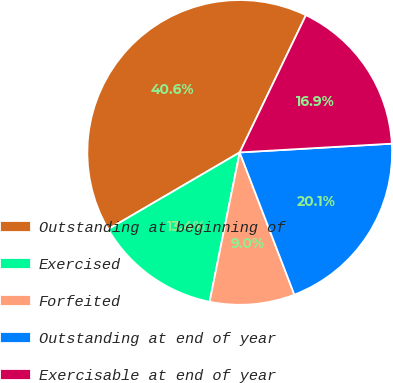<chart> <loc_0><loc_0><loc_500><loc_500><pie_chart><fcel>Outstanding at beginning of<fcel>Exercised<fcel>Forfeited<fcel>Outstanding at end of year<fcel>Exercisable at end of year<nl><fcel>40.57%<fcel>13.42%<fcel>9.0%<fcel>20.08%<fcel>16.93%<nl></chart> 